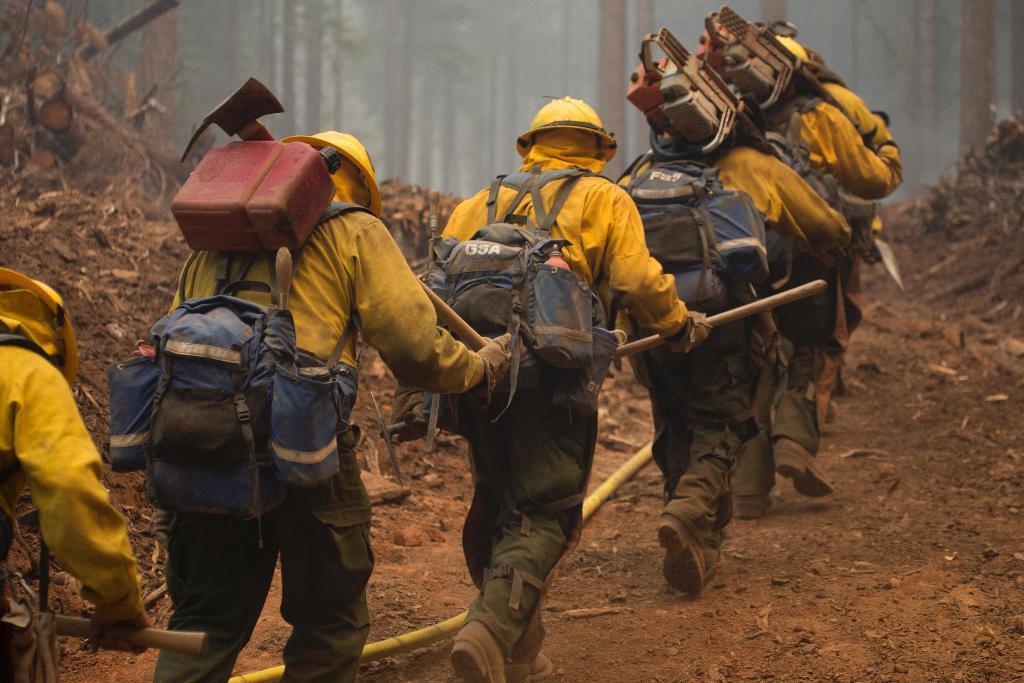In one or two sentences, can you explain what this image depicts? In this image I can see few persons wearing yellow and blue colored dress are standing and holding few objects in their hands. I can see they are carrying few tools with them. I can see the ground and a yellow colored pipe on the ground. In the background I can see few trees. 